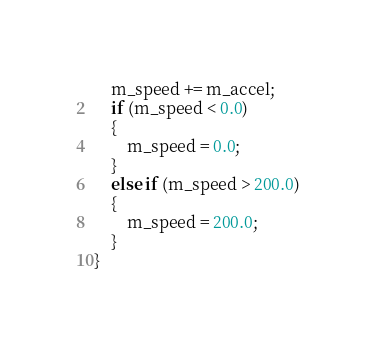<code> <loc_0><loc_0><loc_500><loc_500><_C++_>    m_speed += m_accel;
    if (m_speed < 0.0)
    {
        m_speed = 0.0;
    }
    else if (m_speed > 200.0)
    {
        m_speed = 200.0;
    }
}
</code> 